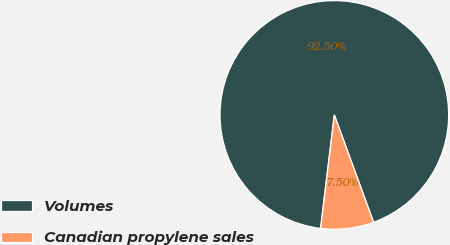Convert chart. <chart><loc_0><loc_0><loc_500><loc_500><pie_chart><fcel>Volumes<fcel>Canadian propylene sales<nl><fcel>92.5%<fcel>7.5%<nl></chart> 